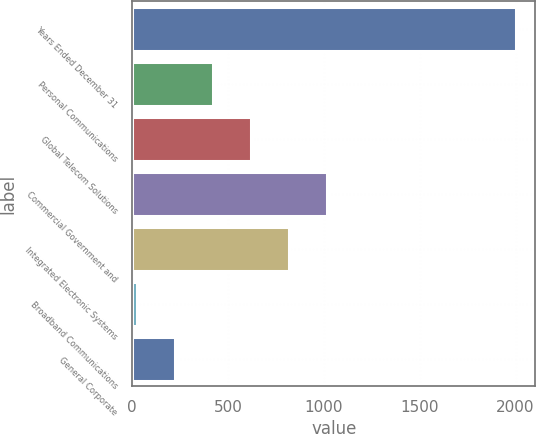<chart> <loc_0><loc_0><loc_500><loc_500><bar_chart><fcel>Years Ended December 31<fcel>Personal Communications<fcel>Global Telecom Solutions<fcel>Commercial Government and<fcel>Integrated Electronic Systems<fcel>Broadband Communications<fcel>General Corporate<nl><fcel>2004<fcel>422.4<fcel>620.1<fcel>1015.5<fcel>817.8<fcel>27<fcel>224.7<nl></chart> 